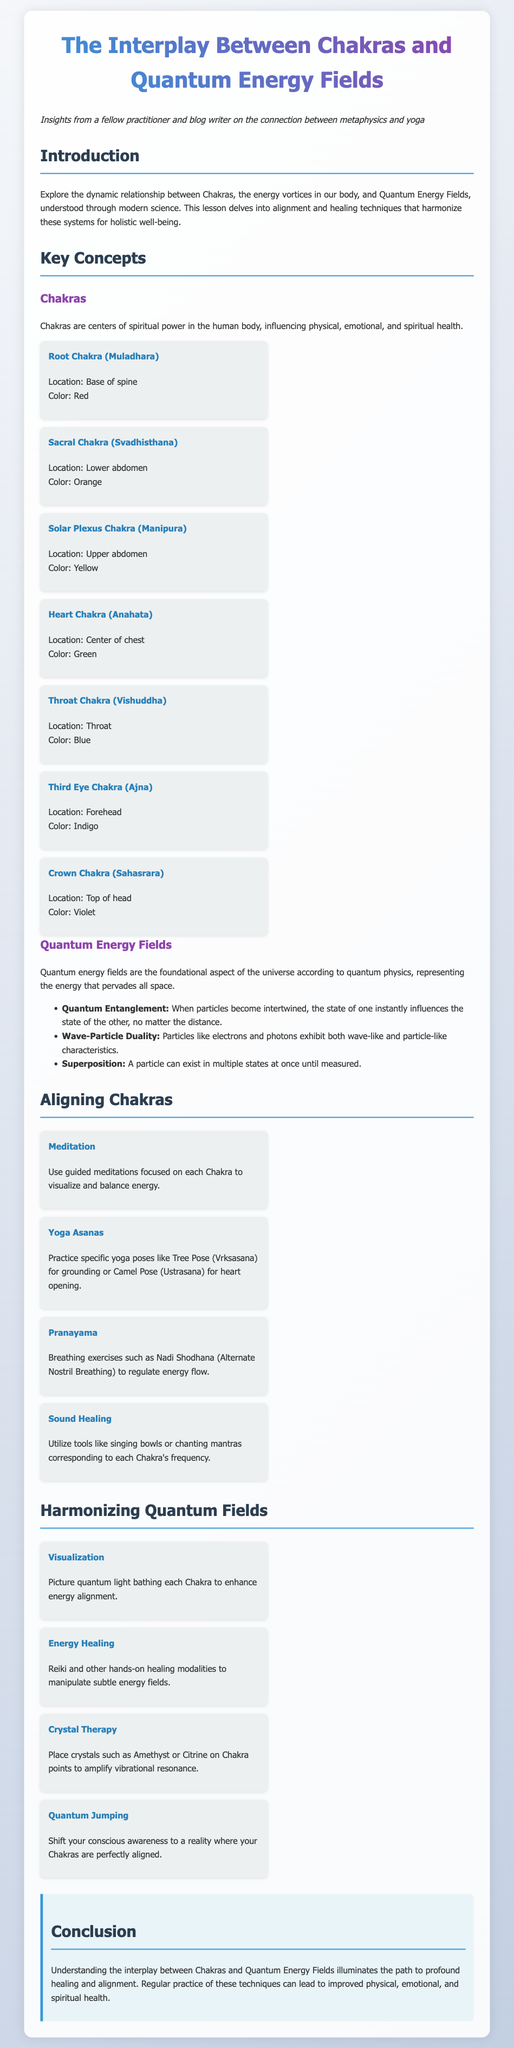What are Chakras? Chakras are centers of spiritual power in the human body, influencing physical, emotional, and spiritual health.
Answer: Centers of spiritual power How many Chakras are listed? The document lists all seven major Chakras in the Chakra section.
Answer: Seven What is the color of the Heart Chakra? The color associated with the Heart Chakra is mentioned as green in the document.
Answer: Green What technique uses breathing exercises? The technique that utilizes breathing exercises is specified in the Pranayama section.
Answer: Pranayama What is one method to harmonize Quantum Fields? The document provides several methods, one of which is Energy Healing.
Answer: Energy Healing Where is the Solar Plexus Chakra located? The location of the Solar Plexus Chakra is stated in the Chakra section of the document.
Answer: Upper abdomen How does Quantum Entanglement affect particles? Quantum Entanglement states that the state of one particle influences the state of the other, no matter the distance.
Answer: Instantly influences What is the focus of the meditation technique? The meditation technique is focused on visualizing and balancing energy in each Chakra.
Answer: Visualize and balance energy What is the concluding message of the lesson plan? The conclusion emphasizes understanding the interplay for healing and alignment in health.
Answer: Healing and alignment 